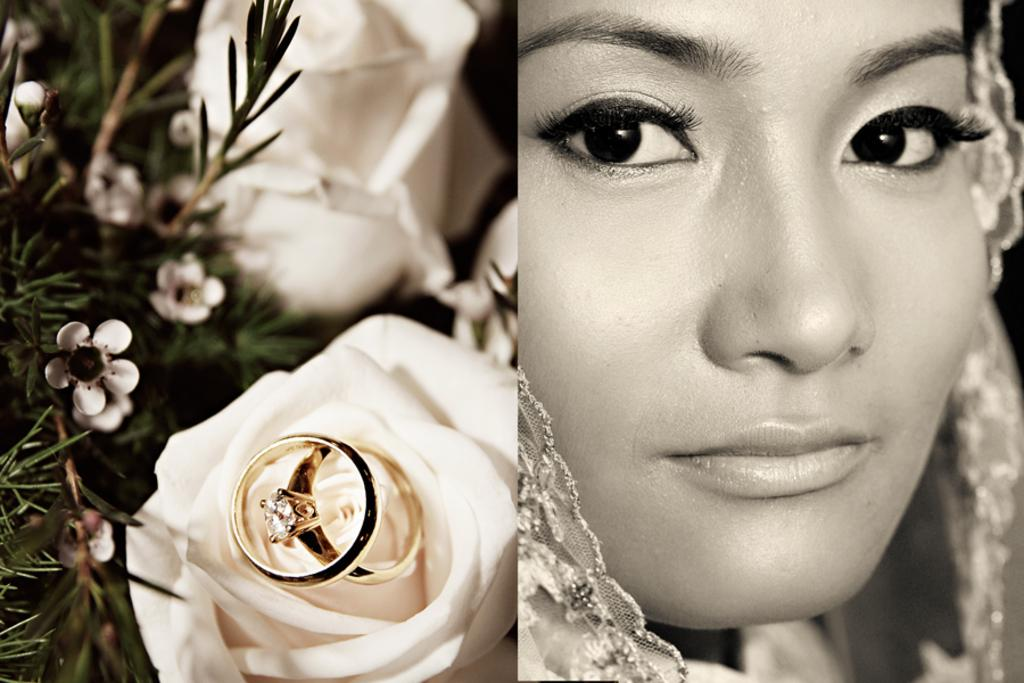Who or what is on the right side of the image? There is a person on the right side of the image. What can be seen on the left side of the image? There are rings, flowers, and leaves on the left side of the image. Can you describe the objects on the left side of the image in more detail? The rings appear to be decorative, while the flowers and leaves are likely part of a floral arrangement or natural setting. How does the person on the right side of the image blow the leaves on the left side of the image? There is no indication in the image that the person is blowing the leaves; they are simply present in the image. What type of vest is the person wearing in the image? There is no vest visible in the image; the person is not wearing any clothing that resembles a vest. 